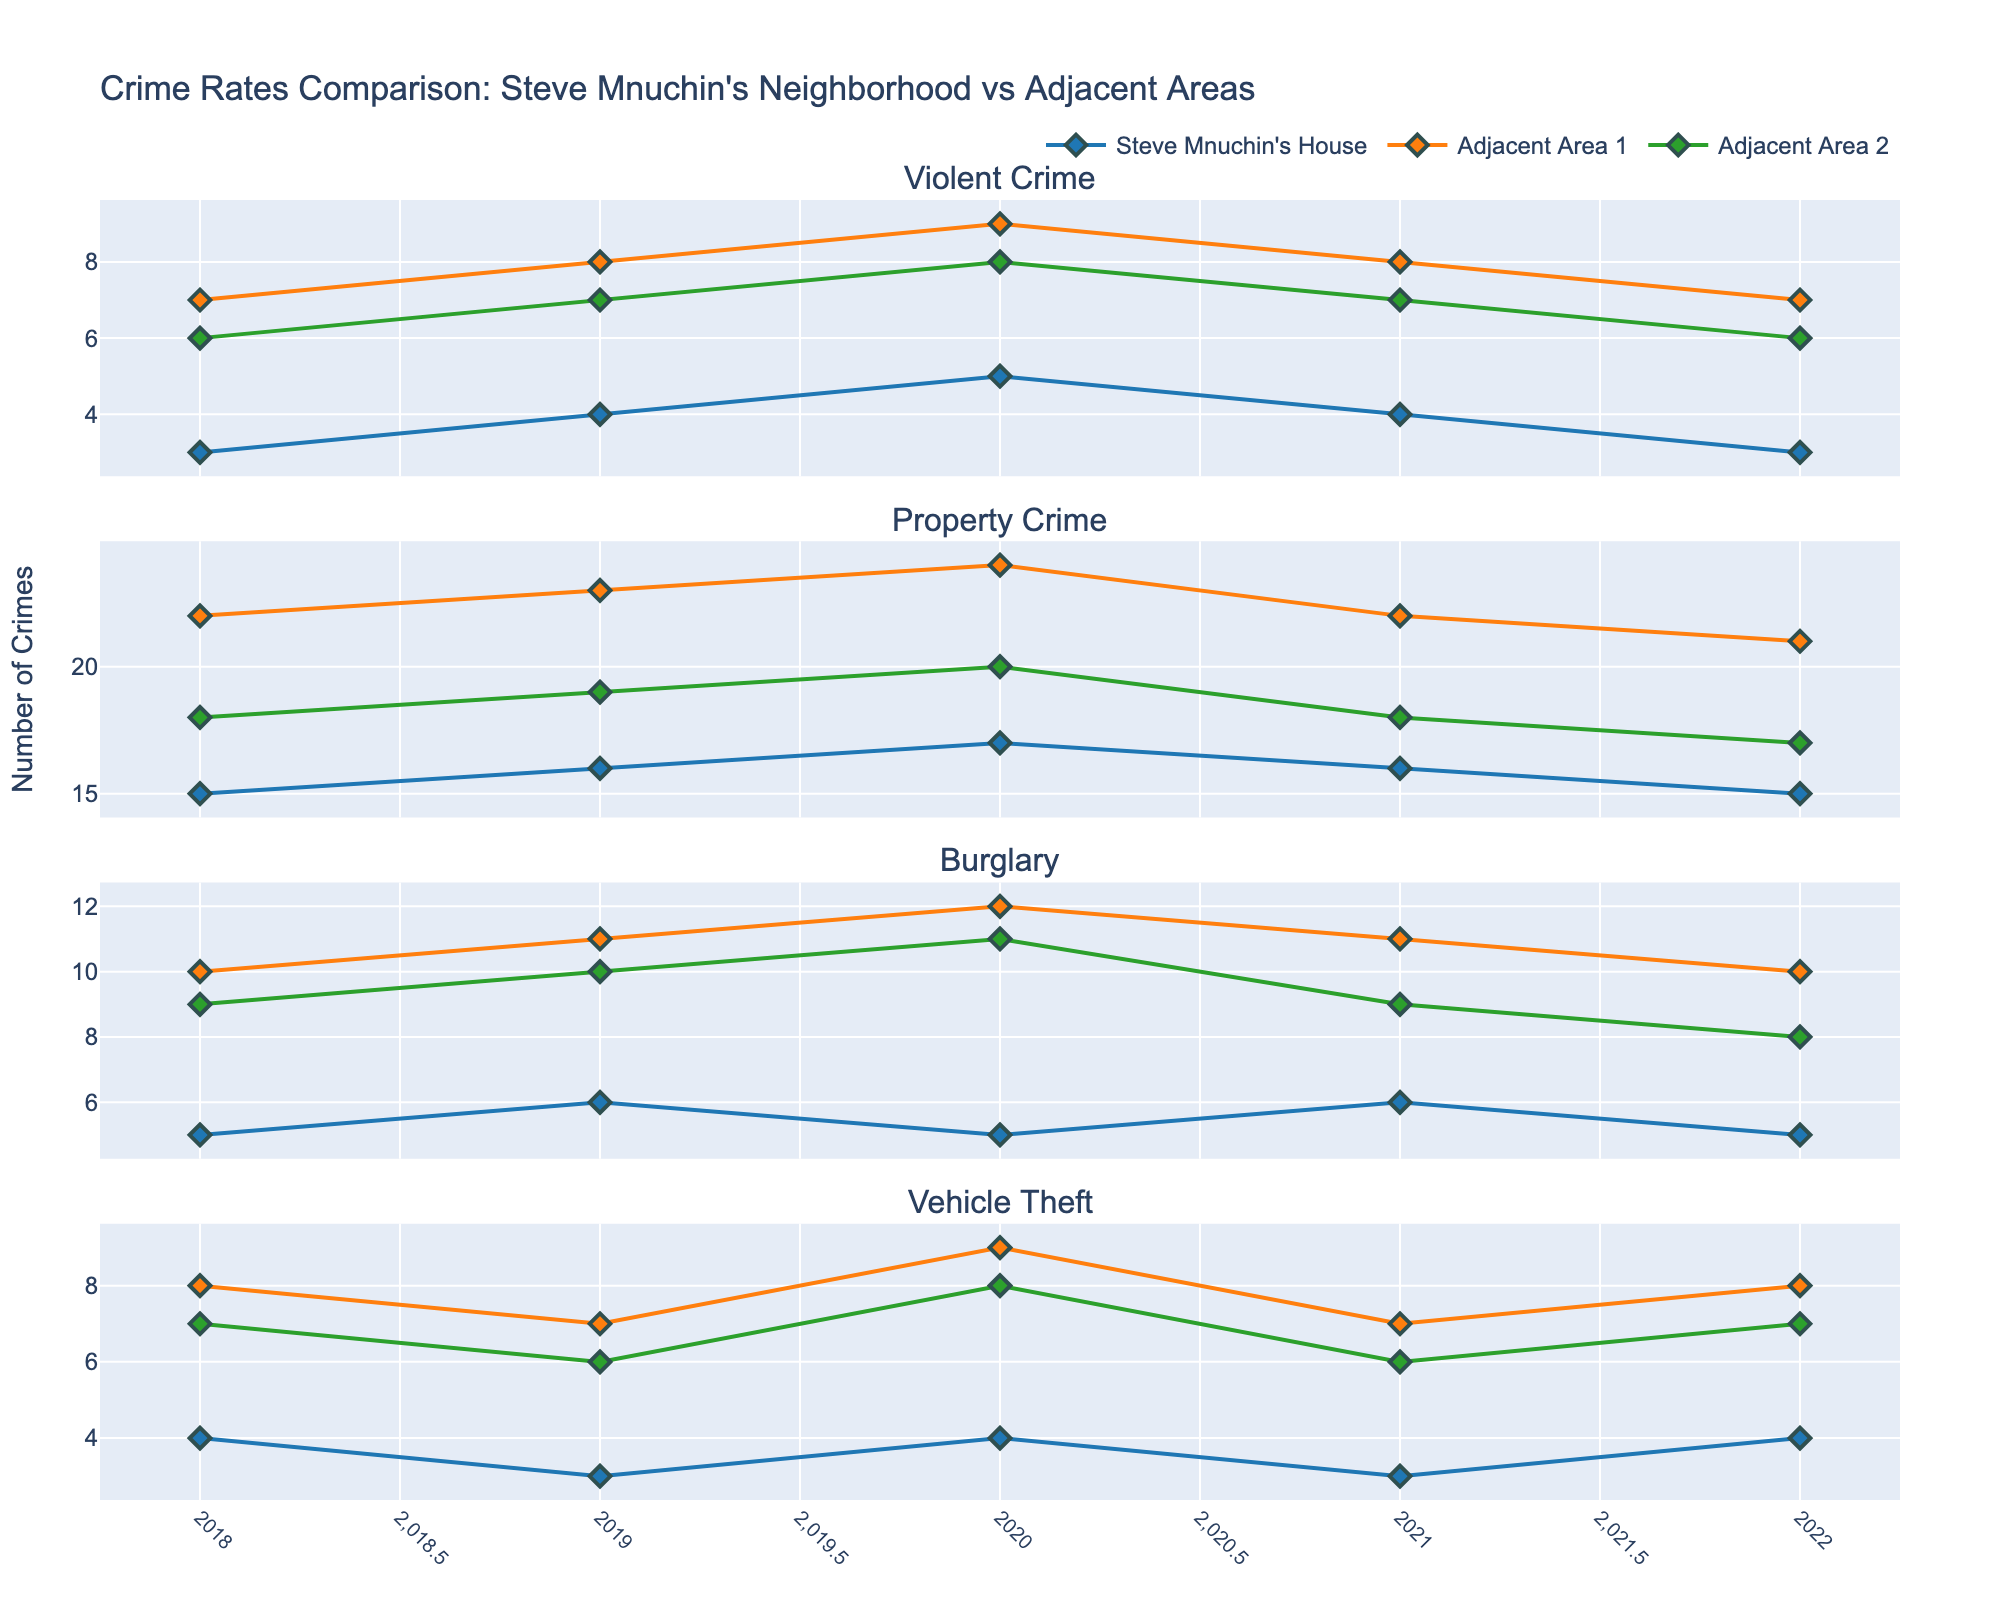What's the dominant color in the legend for Steve Mnuchin's House? The legend lists different areas with lines of different colors. By checking the colors in the legend, we see that Steve Mnuchin's House is represented by blue.
Answer: Blue Which year had the highest number of violent crimes for Steve Mnuchin's House? Observing the subplots for Violent Crime, the line representing Steve Mnuchin's House is highest in the year 2020 with a count of 5.
Answer: 2020 What's the average number of vehicle theft incidents in Adjacent Area 1 over the 5 years? Sum the vehicle theft numbers for Adjacent Area 1 (8, 7, 9, 7, 8), which is 39. Divide by 5 years: 39/5 = 7.8.
Answer: 7.8 Which area had the lowest number of property crimes in 2020? Observing the property crime plot for 2020, Steve Mnuchin's House had the lowest count with 17 crimes compared to 24 in Adjacent Area 1 and 20 in Adjacent Area 2.
Answer: Steve Mnuchin's House By what percentage did the number of burglaries change from 2019 to 2021 for Steve Mnuchin's House? In 2019, there were 6 burglaries. In 2021, there were also 6 burglaries. The percentage change is calculated as: ((6-6)/6) * 100 = 0%.
Answer: 0% Which area saw the biggest decrease in violent crimes from 2020 to 2022? Comparing violent crime numbers: Steve Mnuchin's House went from 5 to 3 (decrease of 2), Adjacent Area 1 from 9 to 7 (decrease of 2), and Adjacent Area 2 from 8 to 6 (decrease of 2). All areas had the same decrease of 2.
Answer: All areas Are there any years where all three areas had the same number of vehicle thefts? After observing the plot for vehicle thefts, there is no year where Steve Mnuchin's House, Adjacent Area 1, and Adjacent Area 2 had the same count.
Answer: No How do property crimes in 2020 compare between Steve Mnuchin's House and Adjacent Area 2? Comparing the numbers, in 2020, Steve Mnuchin's House had 17 property crimes, while Adjacent Area 2 had 20. Therefore, property crimes in Steve Mnuchin's House were fewer.
Answer: Steve Mnuchin's House had fewer 